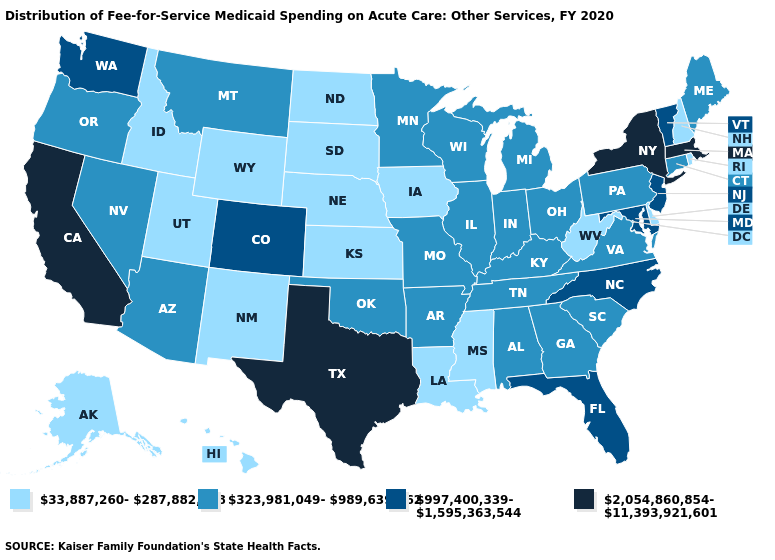Which states have the highest value in the USA?
Give a very brief answer. California, Massachusetts, New York, Texas. Among the states that border Kentucky , does West Virginia have the highest value?
Quick response, please. No. Name the states that have a value in the range 2,054,860,854-11,393,921,601?
Quick response, please. California, Massachusetts, New York, Texas. Among the states that border Kansas , does Colorado have the highest value?
Short answer required. Yes. What is the value of South Dakota?
Answer briefly. 33,887,260-287,882,218. Among the states that border Ohio , which have the lowest value?
Be succinct. West Virginia. Name the states that have a value in the range 33,887,260-287,882,218?
Concise answer only. Alaska, Delaware, Hawaii, Idaho, Iowa, Kansas, Louisiana, Mississippi, Nebraska, New Hampshire, New Mexico, North Dakota, Rhode Island, South Dakota, Utah, West Virginia, Wyoming. What is the value of Massachusetts?
Write a very short answer. 2,054,860,854-11,393,921,601. Among the states that border Mississippi , which have the highest value?
Quick response, please. Alabama, Arkansas, Tennessee. Name the states that have a value in the range 997,400,339-1,595,363,544?
Give a very brief answer. Colorado, Florida, Maryland, New Jersey, North Carolina, Vermont, Washington. Does the first symbol in the legend represent the smallest category?
Concise answer only. Yes. Name the states that have a value in the range 33,887,260-287,882,218?
Answer briefly. Alaska, Delaware, Hawaii, Idaho, Iowa, Kansas, Louisiana, Mississippi, Nebraska, New Hampshire, New Mexico, North Dakota, Rhode Island, South Dakota, Utah, West Virginia, Wyoming. What is the value of California?
Quick response, please. 2,054,860,854-11,393,921,601. What is the highest value in the USA?
Answer briefly. 2,054,860,854-11,393,921,601. Among the states that border Arizona , which have the lowest value?
Quick response, please. New Mexico, Utah. 